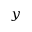Convert formula to latex. <formula><loc_0><loc_0><loc_500><loc_500>_ { y }</formula> 